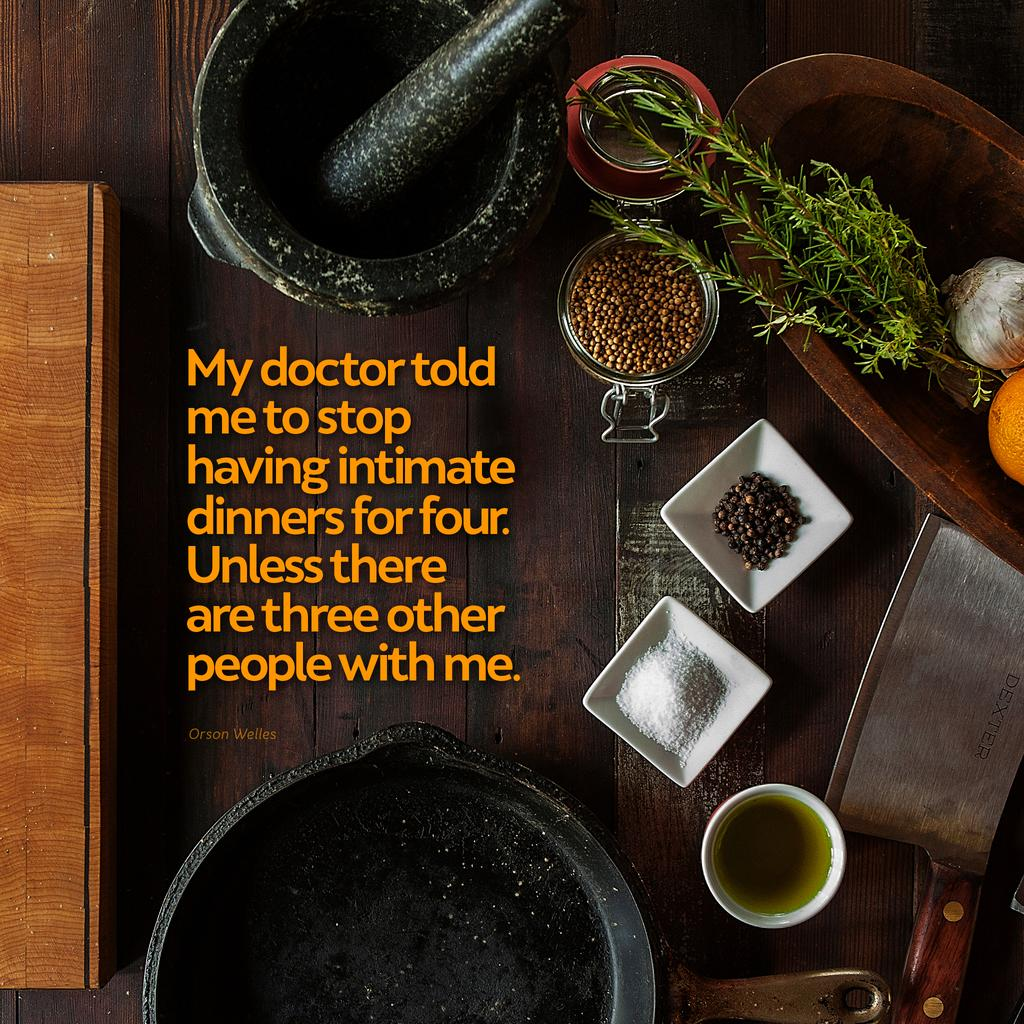What type of items can be seen in the image? There are kitchen items in the image, including a bowl, knife, pan, jar, and garlic. What surface is visible in the image? There is a wooden surface in the image. What other objects can be seen in the image? There is a stone, leaves, and an orange in the image. Can you see any steam coming from the pan in the image? There is no steam visible in the image; it only shows the pan and other objects. Is there a club present in the image? There is no club present in the image. 